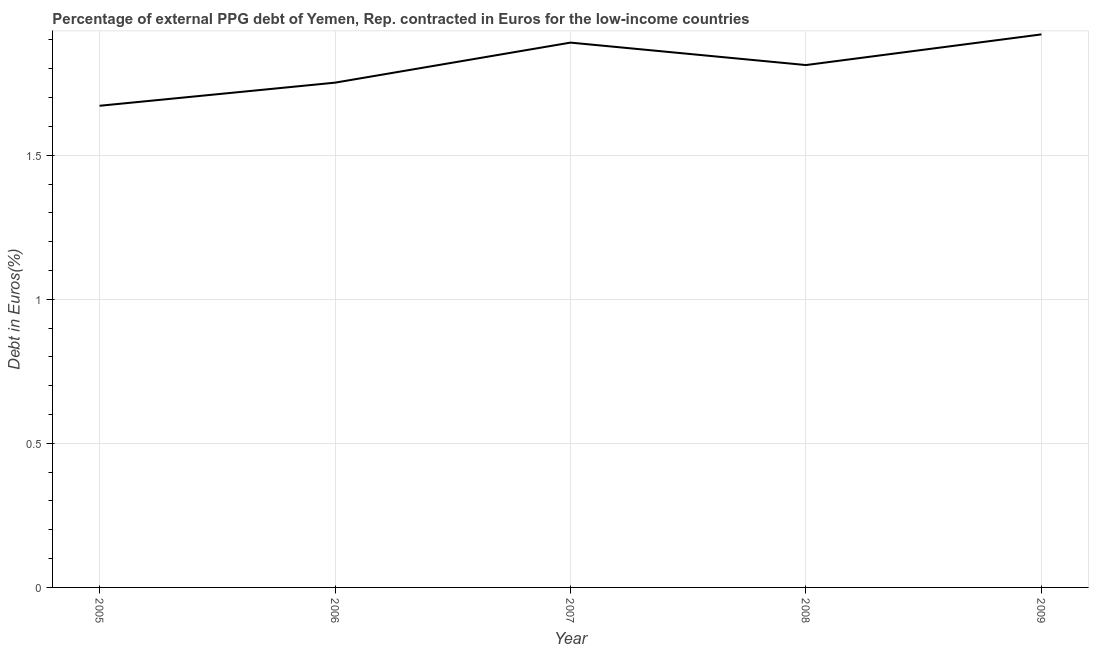What is the currency composition of ppg debt in 2009?
Give a very brief answer. 1.92. Across all years, what is the maximum currency composition of ppg debt?
Provide a succinct answer. 1.92. Across all years, what is the minimum currency composition of ppg debt?
Offer a very short reply. 1.67. In which year was the currency composition of ppg debt maximum?
Keep it short and to the point. 2009. What is the sum of the currency composition of ppg debt?
Offer a very short reply. 9.05. What is the difference between the currency composition of ppg debt in 2005 and 2008?
Provide a short and direct response. -0.14. What is the average currency composition of ppg debt per year?
Your answer should be compact. 1.81. What is the median currency composition of ppg debt?
Offer a very short reply. 1.81. In how many years, is the currency composition of ppg debt greater than 1.2 %?
Your response must be concise. 5. Do a majority of the years between 2009 and 2005 (inclusive) have currency composition of ppg debt greater than 0.2 %?
Make the answer very short. Yes. What is the ratio of the currency composition of ppg debt in 2006 to that in 2008?
Your response must be concise. 0.97. Is the currency composition of ppg debt in 2006 less than that in 2008?
Ensure brevity in your answer.  Yes. Is the difference between the currency composition of ppg debt in 2005 and 2007 greater than the difference between any two years?
Ensure brevity in your answer.  No. What is the difference between the highest and the second highest currency composition of ppg debt?
Your response must be concise. 0.03. What is the difference between the highest and the lowest currency composition of ppg debt?
Your answer should be compact. 0.25. What is the difference between two consecutive major ticks on the Y-axis?
Offer a very short reply. 0.5. Are the values on the major ticks of Y-axis written in scientific E-notation?
Provide a succinct answer. No. What is the title of the graph?
Offer a very short reply. Percentage of external PPG debt of Yemen, Rep. contracted in Euros for the low-income countries. What is the label or title of the X-axis?
Make the answer very short. Year. What is the label or title of the Y-axis?
Provide a short and direct response. Debt in Euros(%). What is the Debt in Euros(%) in 2005?
Your response must be concise. 1.67. What is the Debt in Euros(%) of 2006?
Provide a short and direct response. 1.75. What is the Debt in Euros(%) in 2007?
Offer a very short reply. 1.89. What is the Debt in Euros(%) in 2008?
Your answer should be very brief. 1.81. What is the Debt in Euros(%) in 2009?
Ensure brevity in your answer.  1.92. What is the difference between the Debt in Euros(%) in 2005 and 2006?
Your response must be concise. -0.08. What is the difference between the Debt in Euros(%) in 2005 and 2007?
Provide a short and direct response. -0.22. What is the difference between the Debt in Euros(%) in 2005 and 2008?
Ensure brevity in your answer.  -0.14. What is the difference between the Debt in Euros(%) in 2005 and 2009?
Provide a succinct answer. -0.25. What is the difference between the Debt in Euros(%) in 2006 and 2007?
Your response must be concise. -0.14. What is the difference between the Debt in Euros(%) in 2006 and 2008?
Your response must be concise. -0.06. What is the difference between the Debt in Euros(%) in 2006 and 2009?
Your response must be concise. -0.17. What is the difference between the Debt in Euros(%) in 2007 and 2008?
Make the answer very short. 0.08. What is the difference between the Debt in Euros(%) in 2007 and 2009?
Provide a succinct answer. -0.03. What is the difference between the Debt in Euros(%) in 2008 and 2009?
Offer a very short reply. -0.11. What is the ratio of the Debt in Euros(%) in 2005 to that in 2006?
Offer a very short reply. 0.95. What is the ratio of the Debt in Euros(%) in 2005 to that in 2007?
Ensure brevity in your answer.  0.88. What is the ratio of the Debt in Euros(%) in 2005 to that in 2008?
Provide a short and direct response. 0.92. What is the ratio of the Debt in Euros(%) in 2005 to that in 2009?
Offer a terse response. 0.87. What is the ratio of the Debt in Euros(%) in 2006 to that in 2007?
Your answer should be very brief. 0.93. What is the ratio of the Debt in Euros(%) in 2006 to that in 2008?
Your response must be concise. 0.97. What is the ratio of the Debt in Euros(%) in 2006 to that in 2009?
Provide a succinct answer. 0.91. What is the ratio of the Debt in Euros(%) in 2007 to that in 2008?
Your response must be concise. 1.04. What is the ratio of the Debt in Euros(%) in 2008 to that in 2009?
Offer a terse response. 0.94. 